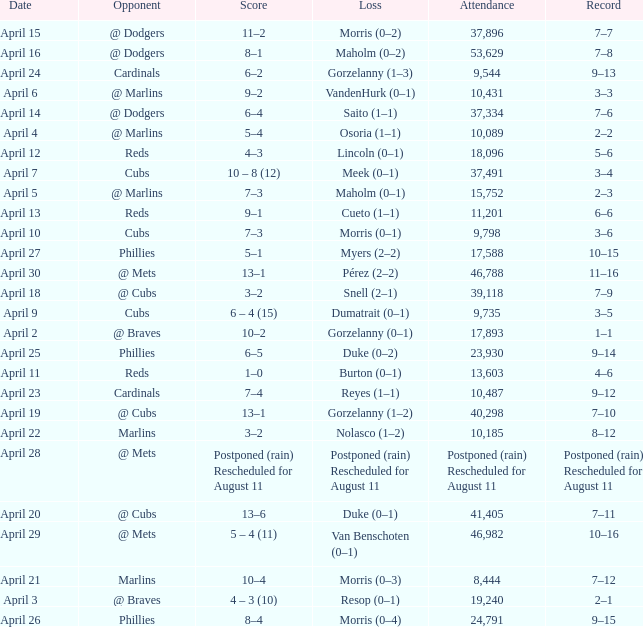What opponent had an attendance of 10,089? @ Marlins. 